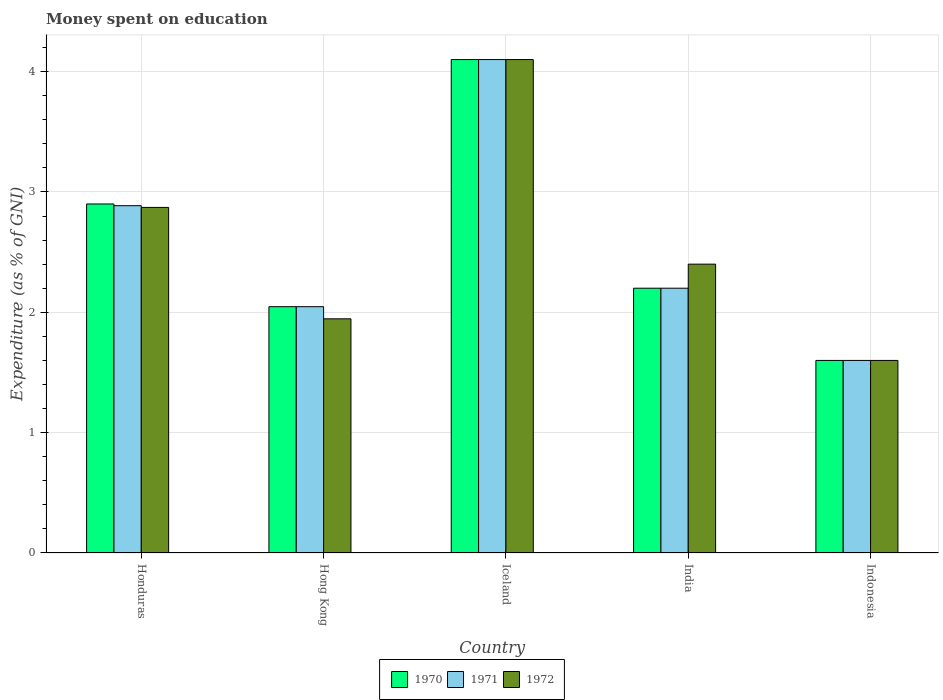How many groups of bars are there?
Offer a terse response. 5. Are the number of bars on each tick of the X-axis equal?
Provide a short and direct response. Yes. How many bars are there on the 2nd tick from the left?
Give a very brief answer. 3. What is the label of the 4th group of bars from the left?
Your answer should be compact. India. In how many cases, is the number of bars for a given country not equal to the number of legend labels?
Your answer should be compact. 0. What is the amount of money spent on education in 1970 in Honduras?
Offer a terse response. 2.9. Across all countries, what is the minimum amount of money spent on education in 1970?
Keep it short and to the point. 1.6. What is the total amount of money spent on education in 1970 in the graph?
Provide a short and direct response. 12.85. What is the difference between the amount of money spent on education in 1972 in Iceland and that in Indonesia?
Your answer should be very brief. 2.5. What is the difference between the amount of money spent on education in 1972 in Hong Kong and the amount of money spent on education in 1970 in India?
Provide a short and direct response. -0.25. What is the average amount of money spent on education in 1972 per country?
Provide a succinct answer. 2.58. In how many countries, is the amount of money spent on education in 1971 greater than 2 %?
Your answer should be compact. 4. What is the ratio of the amount of money spent on education in 1972 in Honduras to that in India?
Give a very brief answer. 1.2. Is the amount of money spent on education in 1972 in Honduras less than that in Indonesia?
Your answer should be compact. No. Is the difference between the amount of money spent on education in 1970 in Hong Kong and Indonesia greater than the difference between the amount of money spent on education in 1971 in Hong Kong and Indonesia?
Make the answer very short. No. What is the difference between the highest and the second highest amount of money spent on education in 1971?
Offer a very short reply. 0.69. What is the difference between the highest and the lowest amount of money spent on education in 1970?
Make the answer very short. 2.5. What does the 2nd bar from the right in Hong Kong represents?
Keep it short and to the point. 1971. Is it the case that in every country, the sum of the amount of money spent on education in 1972 and amount of money spent on education in 1971 is greater than the amount of money spent on education in 1970?
Your answer should be very brief. Yes. How many bars are there?
Make the answer very short. 15. Are all the bars in the graph horizontal?
Give a very brief answer. No. How many countries are there in the graph?
Keep it short and to the point. 5. What is the difference between two consecutive major ticks on the Y-axis?
Your response must be concise. 1. Are the values on the major ticks of Y-axis written in scientific E-notation?
Give a very brief answer. No. Does the graph contain grids?
Make the answer very short. Yes. What is the title of the graph?
Your answer should be very brief. Money spent on education. Does "2013" appear as one of the legend labels in the graph?
Make the answer very short. No. What is the label or title of the X-axis?
Offer a terse response. Country. What is the label or title of the Y-axis?
Offer a terse response. Expenditure (as % of GNI). What is the Expenditure (as % of GNI) in 1970 in Honduras?
Offer a very short reply. 2.9. What is the Expenditure (as % of GNI) of 1971 in Honduras?
Offer a terse response. 2.89. What is the Expenditure (as % of GNI) of 1972 in Honduras?
Ensure brevity in your answer.  2.87. What is the Expenditure (as % of GNI) of 1970 in Hong Kong?
Provide a succinct answer. 2.05. What is the Expenditure (as % of GNI) of 1971 in Hong Kong?
Offer a very short reply. 2.05. What is the Expenditure (as % of GNI) in 1972 in Hong Kong?
Keep it short and to the point. 1.95. What is the Expenditure (as % of GNI) of 1971 in Iceland?
Your response must be concise. 4.1. What is the Expenditure (as % of GNI) of 1970 in India?
Your response must be concise. 2.2. What is the Expenditure (as % of GNI) in 1971 in India?
Provide a short and direct response. 2.2. What is the Expenditure (as % of GNI) of 1972 in India?
Offer a terse response. 2.4. What is the Expenditure (as % of GNI) of 1972 in Indonesia?
Make the answer very short. 1.6. Across all countries, what is the maximum Expenditure (as % of GNI) of 1970?
Your response must be concise. 4.1. Across all countries, what is the maximum Expenditure (as % of GNI) in 1972?
Make the answer very short. 4.1. Across all countries, what is the minimum Expenditure (as % of GNI) in 1970?
Offer a very short reply. 1.6. Across all countries, what is the minimum Expenditure (as % of GNI) of 1972?
Offer a terse response. 1.6. What is the total Expenditure (as % of GNI) in 1970 in the graph?
Give a very brief answer. 12.85. What is the total Expenditure (as % of GNI) in 1971 in the graph?
Provide a succinct answer. 12.83. What is the total Expenditure (as % of GNI) in 1972 in the graph?
Make the answer very short. 12.92. What is the difference between the Expenditure (as % of GNI) in 1970 in Honduras and that in Hong Kong?
Offer a very short reply. 0.85. What is the difference between the Expenditure (as % of GNI) in 1971 in Honduras and that in Hong Kong?
Give a very brief answer. 0.84. What is the difference between the Expenditure (as % of GNI) in 1972 in Honduras and that in Hong Kong?
Ensure brevity in your answer.  0.93. What is the difference between the Expenditure (as % of GNI) in 1971 in Honduras and that in Iceland?
Provide a succinct answer. -1.21. What is the difference between the Expenditure (as % of GNI) of 1972 in Honduras and that in Iceland?
Your response must be concise. -1.23. What is the difference between the Expenditure (as % of GNI) in 1971 in Honduras and that in India?
Ensure brevity in your answer.  0.69. What is the difference between the Expenditure (as % of GNI) in 1972 in Honduras and that in India?
Provide a short and direct response. 0.47. What is the difference between the Expenditure (as % of GNI) of 1971 in Honduras and that in Indonesia?
Your answer should be very brief. 1.29. What is the difference between the Expenditure (as % of GNI) in 1972 in Honduras and that in Indonesia?
Your response must be concise. 1.27. What is the difference between the Expenditure (as % of GNI) in 1970 in Hong Kong and that in Iceland?
Your answer should be very brief. -2.05. What is the difference between the Expenditure (as % of GNI) in 1971 in Hong Kong and that in Iceland?
Keep it short and to the point. -2.05. What is the difference between the Expenditure (as % of GNI) in 1972 in Hong Kong and that in Iceland?
Offer a terse response. -2.15. What is the difference between the Expenditure (as % of GNI) in 1970 in Hong Kong and that in India?
Provide a short and direct response. -0.15. What is the difference between the Expenditure (as % of GNI) in 1971 in Hong Kong and that in India?
Give a very brief answer. -0.15. What is the difference between the Expenditure (as % of GNI) of 1972 in Hong Kong and that in India?
Give a very brief answer. -0.45. What is the difference between the Expenditure (as % of GNI) in 1970 in Hong Kong and that in Indonesia?
Offer a very short reply. 0.45. What is the difference between the Expenditure (as % of GNI) of 1971 in Hong Kong and that in Indonesia?
Keep it short and to the point. 0.45. What is the difference between the Expenditure (as % of GNI) of 1972 in Hong Kong and that in Indonesia?
Offer a terse response. 0.35. What is the difference between the Expenditure (as % of GNI) in 1970 in Iceland and that in India?
Make the answer very short. 1.9. What is the difference between the Expenditure (as % of GNI) in 1971 in Iceland and that in India?
Provide a succinct answer. 1.9. What is the difference between the Expenditure (as % of GNI) of 1972 in Iceland and that in India?
Offer a terse response. 1.7. What is the difference between the Expenditure (as % of GNI) of 1971 in Iceland and that in Indonesia?
Provide a short and direct response. 2.5. What is the difference between the Expenditure (as % of GNI) in 1972 in Iceland and that in Indonesia?
Keep it short and to the point. 2.5. What is the difference between the Expenditure (as % of GNI) of 1970 in India and that in Indonesia?
Provide a succinct answer. 0.6. What is the difference between the Expenditure (as % of GNI) of 1971 in India and that in Indonesia?
Provide a succinct answer. 0.6. What is the difference between the Expenditure (as % of GNI) in 1972 in India and that in Indonesia?
Your answer should be very brief. 0.8. What is the difference between the Expenditure (as % of GNI) in 1970 in Honduras and the Expenditure (as % of GNI) in 1971 in Hong Kong?
Your answer should be compact. 0.85. What is the difference between the Expenditure (as % of GNI) of 1970 in Honduras and the Expenditure (as % of GNI) of 1972 in Hong Kong?
Ensure brevity in your answer.  0.95. What is the difference between the Expenditure (as % of GNI) of 1971 in Honduras and the Expenditure (as % of GNI) of 1972 in Hong Kong?
Your answer should be very brief. 0.94. What is the difference between the Expenditure (as % of GNI) of 1970 in Honduras and the Expenditure (as % of GNI) of 1971 in Iceland?
Keep it short and to the point. -1.2. What is the difference between the Expenditure (as % of GNI) in 1971 in Honduras and the Expenditure (as % of GNI) in 1972 in Iceland?
Keep it short and to the point. -1.21. What is the difference between the Expenditure (as % of GNI) in 1970 in Honduras and the Expenditure (as % of GNI) in 1971 in India?
Offer a very short reply. 0.7. What is the difference between the Expenditure (as % of GNI) of 1970 in Honduras and the Expenditure (as % of GNI) of 1972 in India?
Provide a succinct answer. 0.5. What is the difference between the Expenditure (as % of GNI) of 1971 in Honduras and the Expenditure (as % of GNI) of 1972 in India?
Give a very brief answer. 0.49. What is the difference between the Expenditure (as % of GNI) of 1970 in Honduras and the Expenditure (as % of GNI) of 1971 in Indonesia?
Your answer should be compact. 1.3. What is the difference between the Expenditure (as % of GNI) of 1970 in Honduras and the Expenditure (as % of GNI) of 1972 in Indonesia?
Make the answer very short. 1.3. What is the difference between the Expenditure (as % of GNI) of 1971 in Honduras and the Expenditure (as % of GNI) of 1972 in Indonesia?
Provide a succinct answer. 1.29. What is the difference between the Expenditure (as % of GNI) in 1970 in Hong Kong and the Expenditure (as % of GNI) in 1971 in Iceland?
Ensure brevity in your answer.  -2.05. What is the difference between the Expenditure (as % of GNI) in 1970 in Hong Kong and the Expenditure (as % of GNI) in 1972 in Iceland?
Offer a terse response. -2.05. What is the difference between the Expenditure (as % of GNI) in 1971 in Hong Kong and the Expenditure (as % of GNI) in 1972 in Iceland?
Make the answer very short. -2.05. What is the difference between the Expenditure (as % of GNI) in 1970 in Hong Kong and the Expenditure (as % of GNI) in 1971 in India?
Give a very brief answer. -0.15. What is the difference between the Expenditure (as % of GNI) in 1970 in Hong Kong and the Expenditure (as % of GNI) in 1972 in India?
Ensure brevity in your answer.  -0.35. What is the difference between the Expenditure (as % of GNI) in 1971 in Hong Kong and the Expenditure (as % of GNI) in 1972 in India?
Ensure brevity in your answer.  -0.35. What is the difference between the Expenditure (as % of GNI) in 1970 in Hong Kong and the Expenditure (as % of GNI) in 1971 in Indonesia?
Give a very brief answer. 0.45. What is the difference between the Expenditure (as % of GNI) of 1970 in Hong Kong and the Expenditure (as % of GNI) of 1972 in Indonesia?
Give a very brief answer. 0.45. What is the difference between the Expenditure (as % of GNI) in 1971 in Hong Kong and the Expenditure (as % of GNI) in 1972 in Indonesia?
Keep it short and to the point. 0.45. What is the difference between the Expenditure (as % of GNI) of 1970 in Iceland and the Expenditure (as % of GNI) of 1971 in India?
Your answer should be very brief. 1.9. What is the difference between the Expenditure (as % of GNI) in 1970 in Iceland and the Expenditure (as % of GNI) in 1971 in Indonesia?
Keep it short and to the point. 2.5. What is the difference between the Expenditure (as % of GNI) of 1971 in Iceland and the Expenditure (as % of GNI) of 1972 in Indonesia?
Your response must be concise. 2.5. What is the difference between the Expenditure (as % of GNI) in 1970 in India and the Expenditure (as % of GNI) in 1971 in Indonesia?
Provide a succinct answer. 0.6. What is the difference between the Expenditure (as % of GNI) in 1971 in India and the Expenditure (as % of GNI) in 1972 in Indonesia?
Give a very brief answer. 0.6. What is the average Expenditure (as % of GNI) in 1970 per country?
Ensure brevity in your answer.  2.57. What is the average Expenditure (as % of GNI) in 1971 per country?
Offer a very short reply. 2.57. What is the average Expenditure (as % of GNI) in 1972 per country?
Your response must be concise. 2.58. What is the difference between the Expenditure (as % of GNI) in 1970 and Expenditure (as % of GNI) in 1971 in Honduras?
Give a very brief answer. 0.01. What is the difference between the Expenditure (as % of GNI) in 1970 and Expenditure (as % of GNI) in 1972 in Honduras?
Your answer should be compact. 0.03. What is the difference between the Expenditure (as % of GNI) in 1971 and Expenditure (as % of GNI) in 1972 in Honduras?
Provide a succinct answer. 0.01. What is the difference between the Expenditure (as % of GNI) of 1970 and Expenditure (as % of GNI) of 1971 in Hong Kong?
Make the answer very short. 0. What is the difference between the Expenditure (as % of GNI) of 1970 and Expenditure (as % of GNI) of 1972 in Hong Kong?
Provide a short and direct response. 0.1. What is the difference between the Expenditure (as % of GNI) of 1971 and Expenditure (as % of GNI) of 1972 in Hong Kong?
Provide a short and direct response. 0.1. What is the difference between the Expenditure (as % of GNI) in 1970 and Expenditure (as % of GNI) in 1971 in Iceland?
Your response must be concise. 0. What is the difference between the Expenditure (as % of GNI) in 1971 and Expenditure (as % of GNI) in 1972 in Iceland?
Make the answer very short. 0. What is the difference between the Expenditure (as % of GNI) in 1970 and Expenditure (as % of GNI) in 1971 in India?
Give a very brief answer. 0. What is the difference between the Expenditure (as % of GNI) in 1970 and Expenditure (as % of GNI) in 1972 in Indonesia?
Make the answer very short. 0. What is the ratio of the Expenditure (as % of GNI) in 1970 in Honduras to that in Hong Kong?
Offer a very short reply. 1.42. What is the ratio of the Expenditure (as % of GNI) in 1971 in Honduras to that in Hong Kong?
Your answer should be very brief. 1.41. What is the ratio of the Expenditure (as % of GNI) in 1972 in Honduras to that in Hong Kong?
Your response must be concise. 1.48. What is the ratio of the Expenditure (as % of GNI) of 1970 in Honduras to that in Iceland?
Your response must be concise. 0.71. What is the ratio of the Expenditure (as % of GNI) in 1971 in Honduras to that in Iceland?
Provide a short and direct response. 0.7. What is the ratio of the Expenditure (as % of GNI) in 1972 in Honduras to that in Iceland?
Ensure brevity in your answer.  0.7. What is the ratio of the Expenditure (as % of GNI) of 1970 in Honduras to that in India?
Give a very brief answer. 1.32. What is the ratio of the Expenditure (as % of GNI) in 1971 in Honduras to that in India?
Make the answer very short. 1.31. What is the ratio of the Expenditure (as % of GNI) of 1972 in Honduras to that in India?
Offer a terse response. 1.2. What is the ratio of the Expenditure (as % of GNI) of 1970 in Honduras to that in Indonesia?
Offer a very short reply. 1.81. What is the ratio of the Expenditure (as % of GNI) of 1971 in Honduras to that in Indonesia?
Ensure brevity in your answer.  1.8. What is the ratio of the Expenditure (as % of GNI) of 1972 in Honduras to that in Indonesia?
Give a very brief answer. 1.79. What is the ratio of the Expenditure (as % of GNI) in 1970 in Hong Kong to that in Iceland?
Provide a short and direct response. 0.5. What is the ratio of the Expenditure (as % of GNI) in 1971 in Hong Kong to that in Iceland?
Offer a terse response. 0.5. What is the ratio of the Expenditure (as % of GNI) of 1972 in Hong Kong to that in Iceland?
Your answer should be very brief. 0.47. What is the ratio of the Expenditure (as % of GNI) in 1970 in Hong Kong to that in India?
Offer a very short reply. 0.93. What is the ratio of the Expenditure (as % of GNI) of 1971 in Hong Kong to that in India?
Offer a very short reply. 0.93. What is the ratio of the Expenditure (as % of GNI) in 1972 in Hong Kong to that in India?
Give a very brief answer. 0.81. What is the ratio of the Expenditure (as % of GNI) of 1970 in Hong Kong to that in Indonesia?
Offer a terse response. 1.28. What is the ratio of the Expenditure (as % of GNI) in 1971 in Hong Kong to that in Indonesia?
Provide a short and direct response. 1.28. What is the ratio of the Expenditure (as % of GNI) in 1972 in Hong Kong to that in Indonesia?
Provide a succinct answer. 1.22. What is the ratio of the Expenditure (as % of GNI) of 1970 in Iceland to that in India?
Offer a very short reply. 1.86. What is the ratio of the Expenditure (as % of GNI) of 1971 in Iceland to that in India?
Your answer should be very brief. 1.86. What is the ratio of the Expenditure (as % of GNI) in 1972 in Iceland to that in India?
Offer a terse response. 1.71. What is the ratio of the Expenditure (as % of GNI) of 1970 in Iceland to that in Indonesia?
Keep it short and to the point. 2.56. What is the ratio of the Expenditure (as % of GNI) of 1971 in Iceland to that in Indonesia?
Your response must be concise. 2.56. What is the ratio of the Expenditure (as % of GNI) of 1972 in Iceland to that in Indonesia?
Your answer should be compact. 2.56. What is the ratio of the Expenditure (as % of GNI) in 1970 in India to that in Indonesia?
Offer a terse response. 1.38. What is the ratio of the Expenditure (as % of GNI) of 1971 in India to that in Indonesia?
Ensure brevity in your answer.  1.38. What is the ratio of the Expenditure (as % of GNI) in 1972 in India to that in Indonesia?
Keep it short and to the point. 1.5. What is the difference between the highest and the second highest Expenditure (as % of GNI) of 1971?
Offer a very short reply. 1.21. What is the difference between the highest and the second highest Expenditure (as % of GNI) in 1972?
Offer a terse response. 1.23. What is the difference between the highest and the lowest Expenditure (as % of GNI) of 1970?
Give a very brief answer. 2.5. What is the difference between the highest and the lowest Expenditure (as % of GNI) of 1972?
Keep it short and to the point. 2.5. 